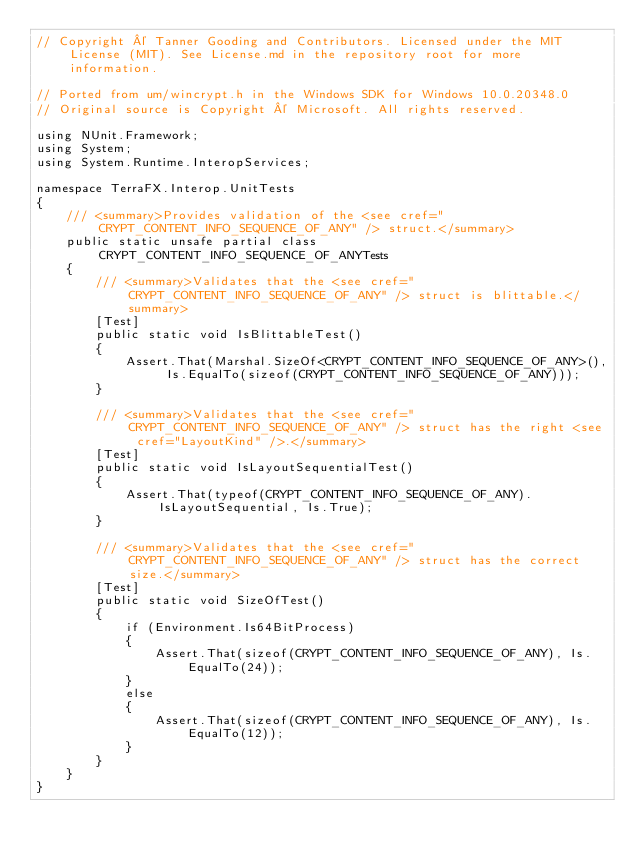<code> <loc_0><loc_0><loc_500><loc_500><_C#_>// Copyright © Tanner Gooding and Contributors. Licensed under the MIT License (MIT). See License.md in the repository root for more information.

// Ported from um/wincrypt.h in the Windows SDK for Windows 10.0.20348.0
// Original source is Copyright © Microsoft. All rights reserved.

using NUnit.Framework;
using System;
using System.Runtime.InteropServices;

namespace TerraFX.Interop.UnitTests
{
    /// <summary>Provides validation of the <see cref="CRYPT_CONTENT_INFO_SEQUENCE_OF_ANY" /> struct.</summary>
    public static unsafe partial class CRYPT_CONTENT_INFO_SEQUENCE_OF_ANYTests
    {
        /// <summary>Validates that the <see cref="CRYPT_CONTENT_INFO_SEQUENCE_OF_ANY" /> struct is blittable.</summary>
        [Test]
        public static void IsBlittableTest()
        {
            Assert.That(Marshal.SizeOf<CRYPT_CONTENT_INFO_SEQUENCE_OF_ANY>(), Is.EqualTo(sizeof(CRYPT_CONTENT_INFO_SEQUENCE_OF_ANY)));
        }

        /// <summary>Validates that the <see cref="CRYPT_CONTENT_INFO_SEQUENCE_OF_ANY" /> struct has the right <see cref="LayoutKind" />.</summary>
        [Test]
        public static void IsLayoutSequentialTest()
        {
            Assert.That(typeof(CRYPT_CONTENT_INFO_SEQUENCE_OF_ANY).IsLayoutSequential, Is.True);
        }

        /// <summary>Validates that the <see cref="CRYPT_CONTENT_INFO_SEQUENCE_OF_ANY" /> struct has the correct size.</summary>
        [Test]
        public static void SizeOfTest()
        {
            if (Environment.Is64BitProcess)
            {
                Assert.That(sizeof(CRYPT_CONTENT_INFO_SEQUENCE_OF_ANY), Is.EqualTo(24));
            }
            else
            {
                Assert.That(sizeof(CRYPT_CONTENT_INFO_SEQUENCE_OF_ANY), Is.EqualTo(12));
            }
        }
    }
}
</code> 